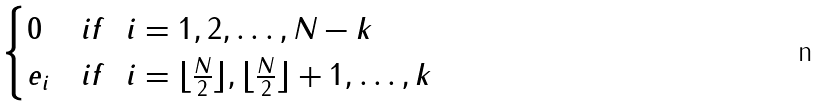<formula> <loc_0><loc_0><loc_500><loc_500>\begin{cases} 0 & i f \ \ i = 1 , 2 , \dots , N - k \\ e _ { i } & i f \ \ i = \lfloor \frac { N } { 2 } \rfloor , \lfloor \frac { N } { 2 } \rfloor + 1 , \dots , k \end{cases}</formula> 